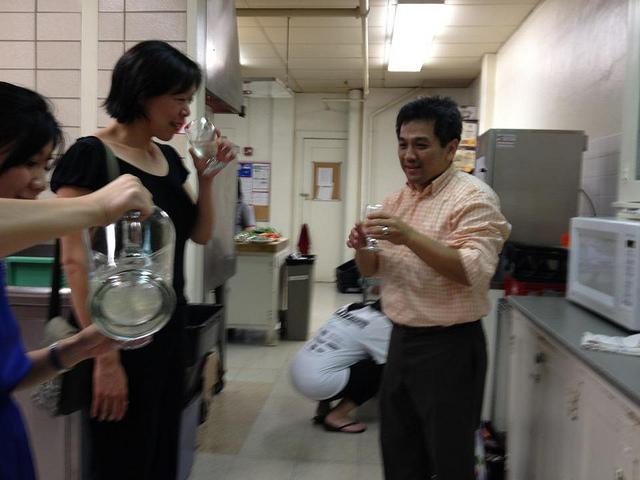Was this picture taken in a workplace?
Answer briefly. Yes. Do these people appear to be happy?
Keep it brief. Yes. What is the man holding in his hand?
Concise answer only. Glass. 